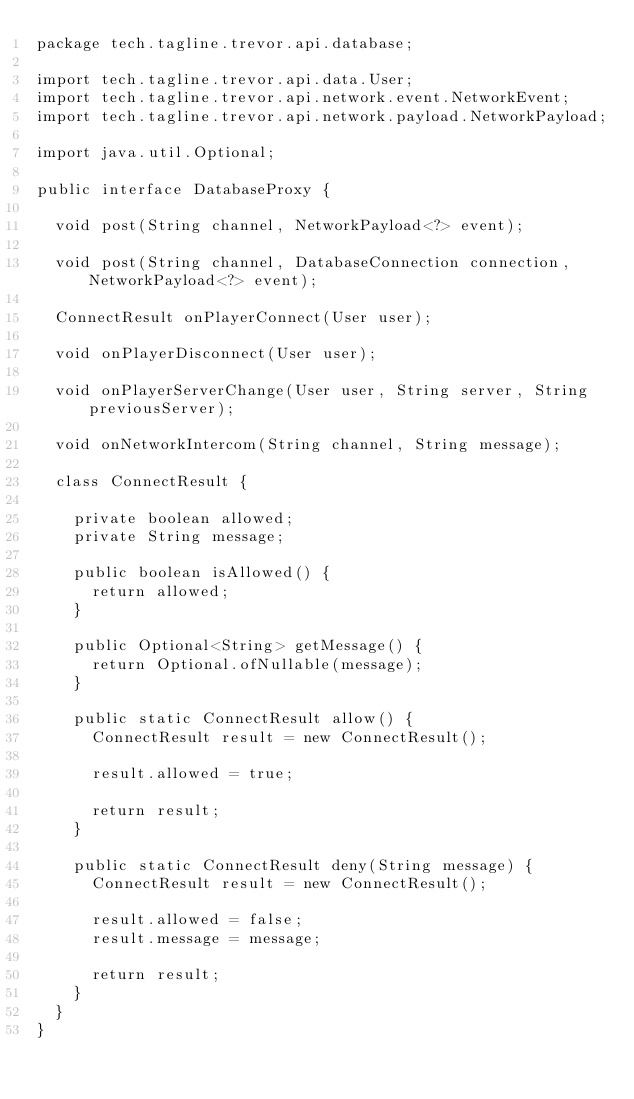<code> <loc_0><loc_0><loc_500><loc_500><_Java_>package tech.tagline.trevor.api.database;

import tech.tagline.trevor.api.data.User;
import tech.tagline.trevor.api.network.event.NetworkEvent;
import tech.tagline.trevor.api.network.payload.NetworkPayload;

import java.util.Optional;

public interface DatabaseProxy {

  void post(String channel, NetworkPayload<?> event);

  void post(String channel, DatabaseConnection connection, NetworkPayload<?> event);

  ConnectResult onPlayerConnect(User user);

  void onPlayerDisconnect(User user);

  void onPlayerServerChange(User user, String server, String previousServer);

  void onNetworkIntercom(String channel, String message);

  class ConnectResult {

    private boolean allowed;
    private String message;

    public boolean isAllowed() {
      return allowed;
    }

    public Optional<String> getMessage() {
      return Optional.ofNullable(message);
    }

    public static ConnectResult allow() {
      ConnectResult result = new ConnectResult();

      result.allowed = true;

      return result;
    }

    public static ConnectResult deny(String message) {
      ConnectResult result = new ConnectResult();

      result.allowed = false;
      result.message = message;

      return result;
    }
  }
}
</code> 